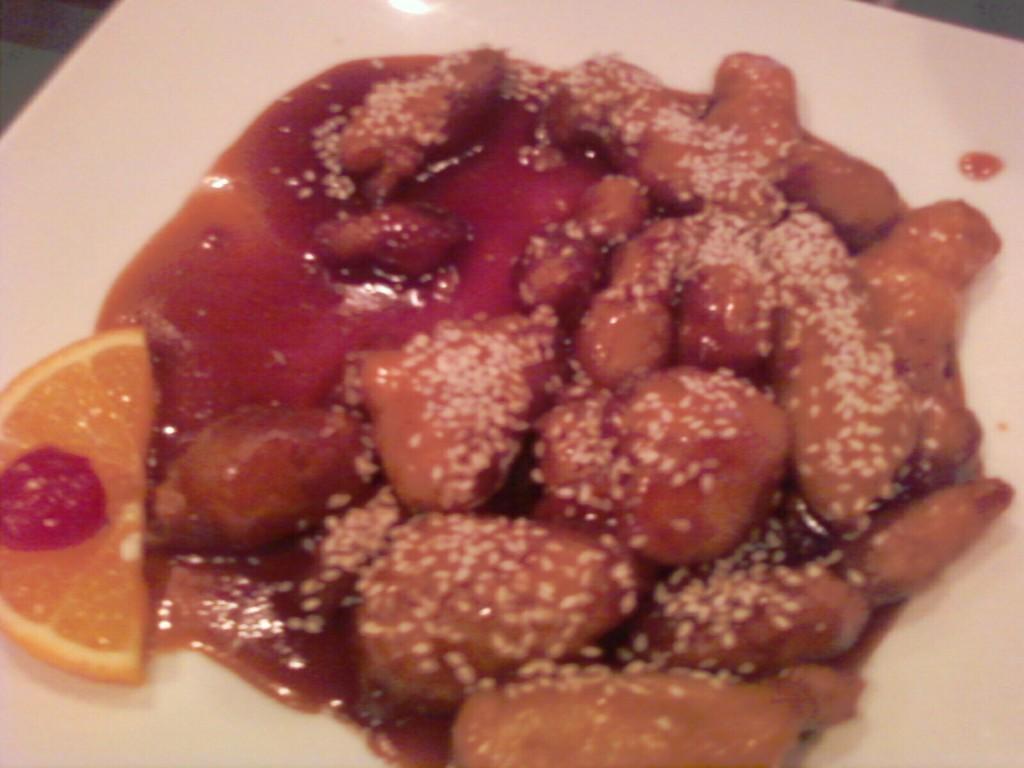Describe this image in one or two sentences. In this image I can see a white colored plate and on it I can see a food item which is brown, white, red and orange in color. 